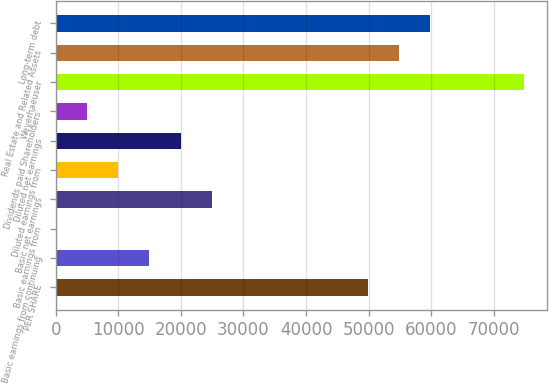Convert chart. <chart><loc_0><loc_0><loc_500><loc_500><bar_chart><fcel>PER SHARE<fcel>Basic earnings from continuing<fcel>Basic earnings from<fcel>Basic net earnings<fcel>Diluted earnings from<fcel>Diluted net earnings<fcel>Dividends paid Shareholders'<fcel>Weyerhaeuser<fcel>Real Estate and Related Assets<fcel>Long-term debt<nl><fcel>49887<fcel>14966.6<fcel>0.67<fcel>24943.8<fcel>9977.93<fcel>19955.2<fcel>4989.3<fcel>74830.1<fcel>54875.6<fcel>59864.2<nl></chart> 